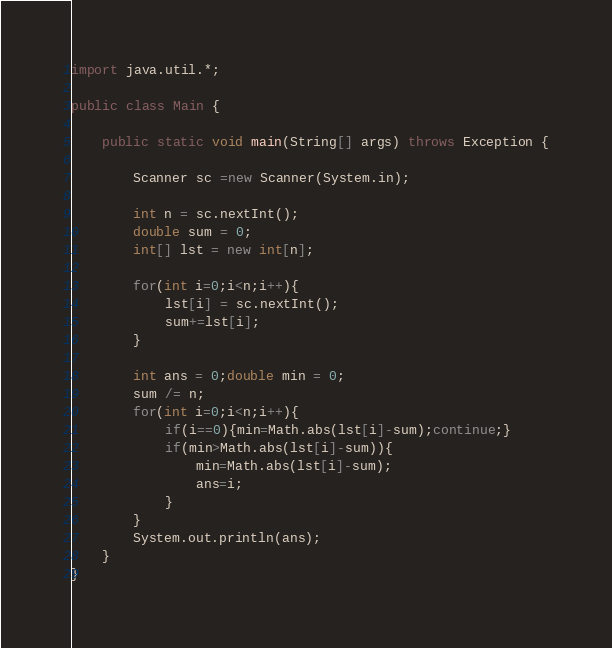Convert code to text. <code><loc_0><loc_0><loc_500><loc_500><_Java_>import java.util.*;

public class Main {

    public static void main(String[] args) throws Exception {
            
        Scanner sc =new Scanner(System.in);
    
        int n = sc.nextInt();
        double sum = 0;
        int[] lst = new int[n];
    
        for(int i=0;i<n;i++){
            lst[i] = sc.nextInt();
            sum+=lst[i];
        }
        
        int ans = 0;double min = 0;
        sum /= n;
        for(int i=0;i<n;i++){
            if(i==0){min=Math.abs(lst[i]-sum);continue;}
            if(min>Math.abs(lst[i]-sum)){
                min=Math.abs(lst[i]-sum);
                ans=i;
            }
        }
        System.out.println(ans);
    }
}</code> 